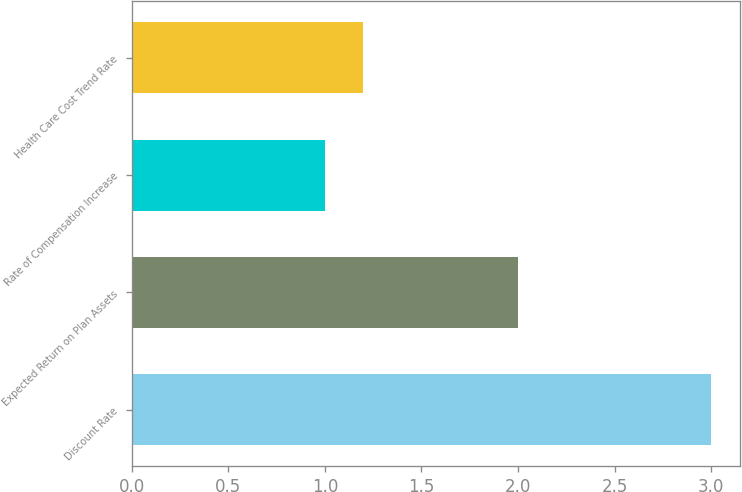Convert chart. <chart><loc_0><loc_0><loc_500><loc_500><bar_chart><fcel>Discount Rate<fcel>Expected Return on Plan Assets<fcel>Rate of Compensation Increase<fcel>Health Care Cost Trend Rate<nl><fcel>3<fcel>2<fcel>1<fcel>1.2<nl></chart> 